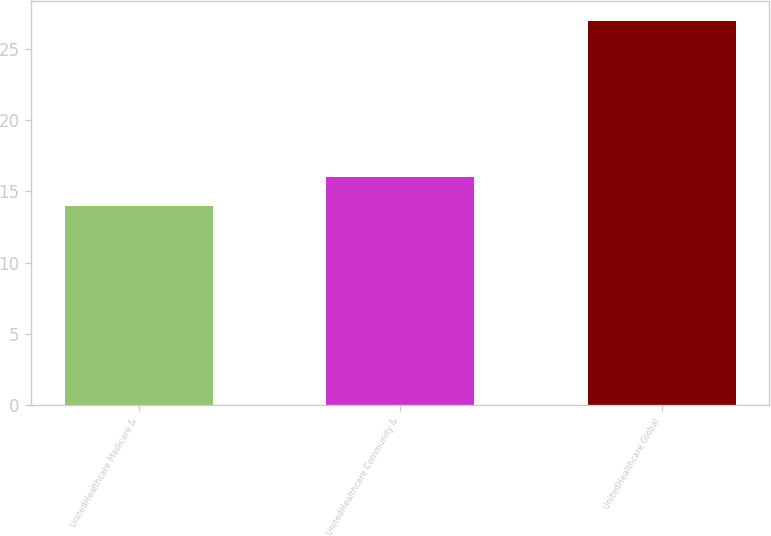Convert chart. <chart><loc_0><loc_0><loc_500><loc_500><bar_chart><fcel>UnitedHealthcare Medicare &<fcel>UnitedHealthcare Community &<fcel>UnitedHealthcare Global<nl><fcel>14<fcel>16<fcel>27<nl></chart> 